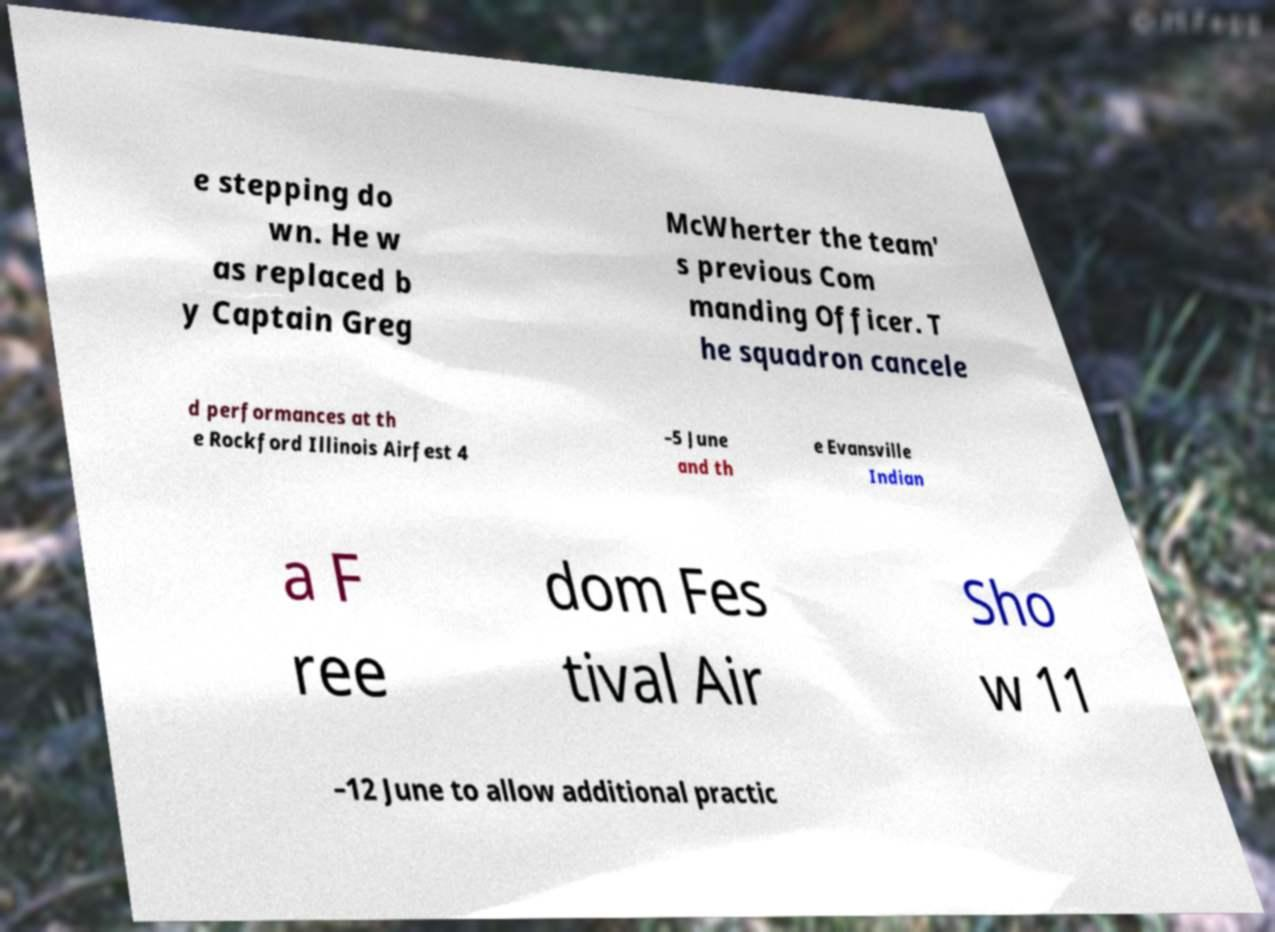Could you extract and type out the text from this image? e stepping do wn. He w as replaced b y Captain Greg McWherter the team' s previous Com manding Officer. T he squadron cancele d performances at th e Rockford Illinois Airfest 4 –5 June and th e Evansville Indian a F ree dom Fes tival Air Sho w 11 –12 June to allow additional practic 